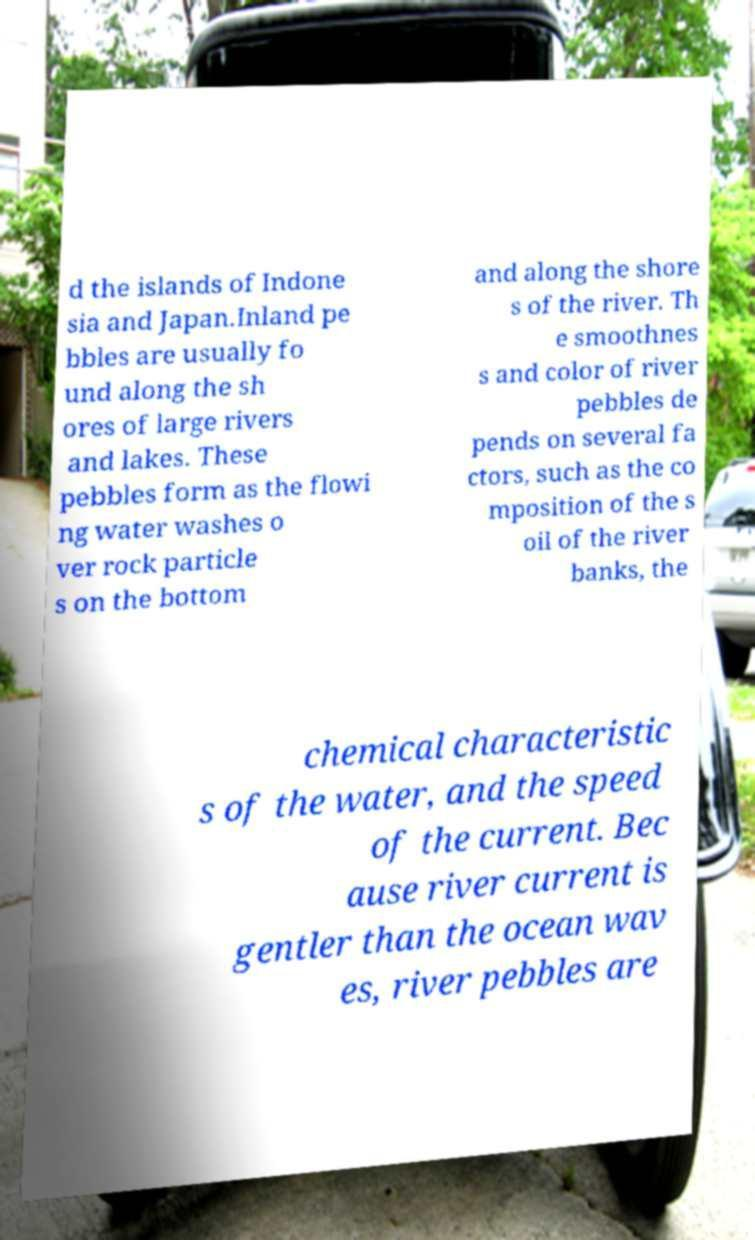Could you extract and type out the text from this image? d the islands of Indone sia and Japan.Inland pe bbles are usually fo und along the sh ores of large rivers and lakes. These pebbles form as the flowi ng water washes o ver rock particle s on the bottom and along the shore s of the river. Th e smoothnes s and color of river pebbles de pends on several fa ctors, such as the co mposition of the s oil of the river banks, the chemical characteristic s of the water, and the speed of the current. Bec ause river current is gentler than the ocean wav es, river pebbles are 